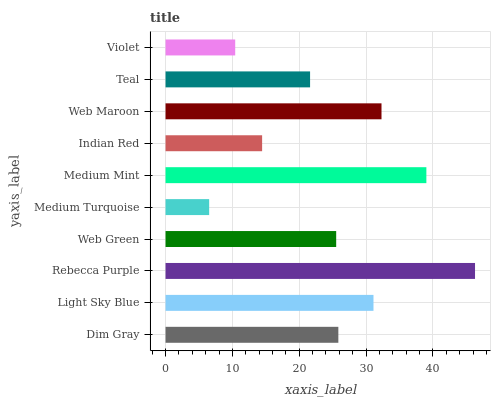Is Medium Turquoise the minimum?
Answer yes or no. Yes. Is Rebecca Purple the maximum?
Answer yes or no. Yes. Is Light Sky Blue the minimum?
Answer yes or no. No. Is Light Sky Blue the maximum?
Answer yes or no. No. Is Light Sky Blue greater than Dim Gray?
Answer yes or no. Yes. Is Dim Gray less than Light Sky Blue?
Answer yes or no. Yes. Is Dim Gray greater than Light Sky Blue?
Answer yes or no. No. Is Light Sky Blue less than Dim Gray?
Answer yes or no. No. Is Dim Gray the high median?
Answer yes or no. Yes. Is Web Green the low median?
Answer yes or no. Yes. Is Web Green the high median?
Answer yes or no. No. Is Light Sky Blue the low median?
Answer yes or no. No. 